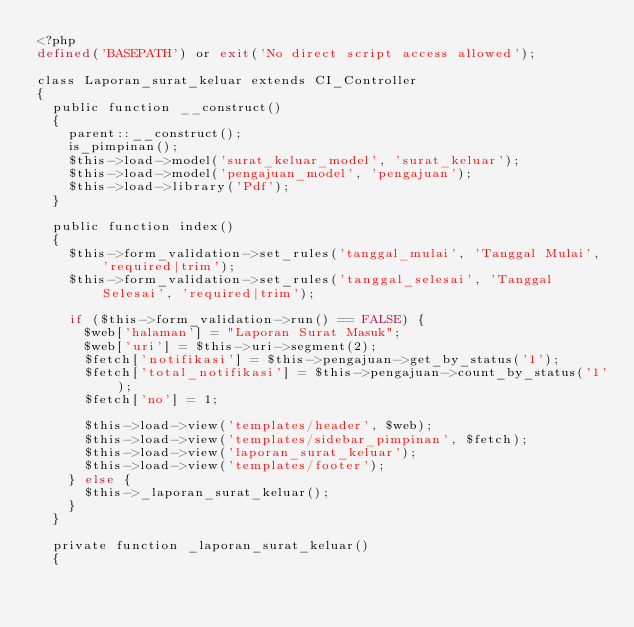Convert code to text. <code><loc_0><loc_0><loc_500><loc_500><_PHP_><?php
defined('BASEPATH') or exit('No direct script access allowed');

class Laporan_surat_keluar extends CI_Controller
{
  public function __construct()
  {
    parent::__construct();
    is_pimpinan();
    $this->load->model('surat_keluar_model', 'surat_keluar');
    $this->load->model('pengajuan_model', 'pengajuan');
    $this->load->library('Pdf');
  }

  public function index()
  {
    $this->form_validation->set_rules('tanggal_mulai', 'Tanggal Mulai', 'required|trim');
    $this->form_validation->set_rules('tanggal_selesai', 'Tanggal Selesai', 'required|trim');

    if ($this->form_validation->run() == FALSE) {
      $web['halaman'] = "Laporan Surat Masuk";
      $web['uri'] = $this->uri->segment(2);
      $fetch['notifikasi'] = $this->pengajuan->get_by_status('1');
      $fetch['total_notifikasi'] = $this->pengajuan->count_by_status('1');
      $fetch['no'] = 1;

      $this->load->view('templates/header', $web);
      $this->load->view('templates/sidebar_pimpinan', $fetch);
      $this->load->view('laporan_surat_keluar');
      $this->load->view('templates/footer');
    } else {
      $this->_laporan_surat_keluar();
    }
  }

  private function _laporan_surat_keluar()
  {</code> 